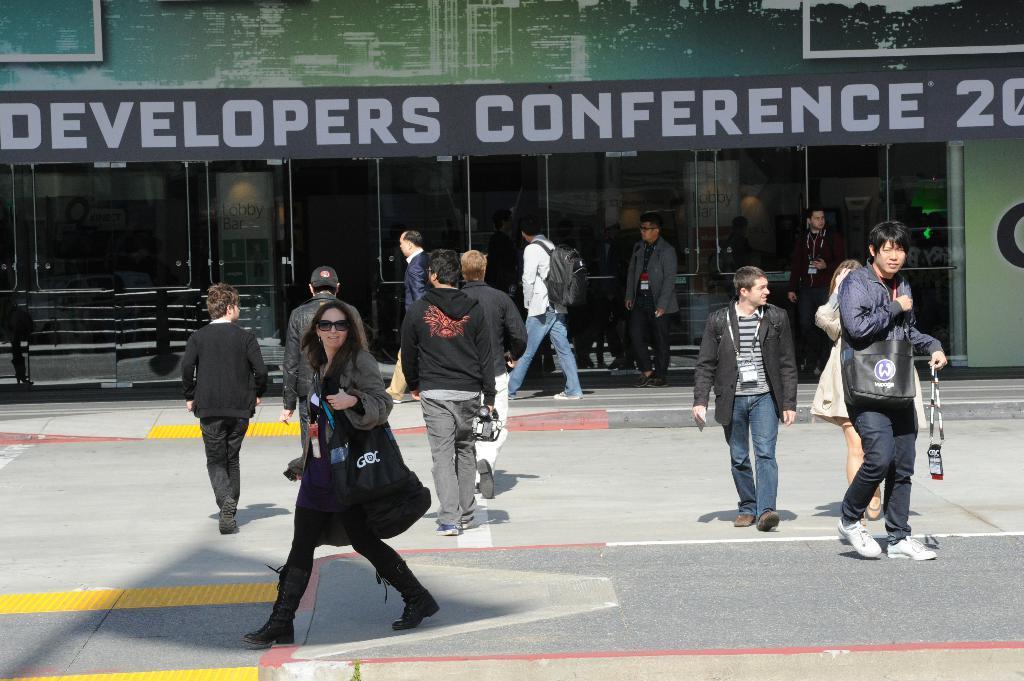Describe this image in one or two sentences. In this image I can see some people walking on the road. In the background, I can see a building with some text written on it. 